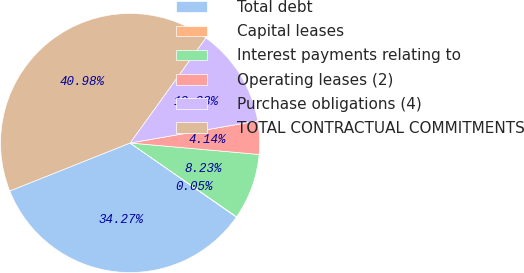Convert chart. <chart><loc_0><loc_0><loc_500><loc_500><pie_chart><fcel>Total debt<fcel>Capital leases<fcel>Interest payments relating to<fcel>Operating leases (2)<fcel>Purchase obligations (4)<fcel>TOTAL CONTRACTUAL COMMITMENTS<nl><fcel>34.27%<fcel>0.05%<fcel>8.23%<fcel>4.14%<fcel>12.33%<fcel>40.98%<nl></chart> 